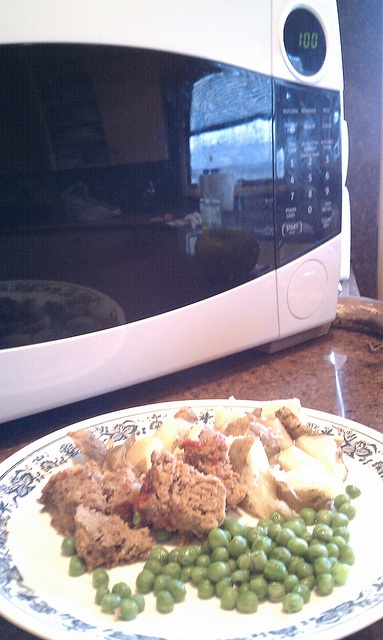Describe the objects in this image and their specific colors. I can see a microwave in ivory, lavender, black, and purple tones in this image. 